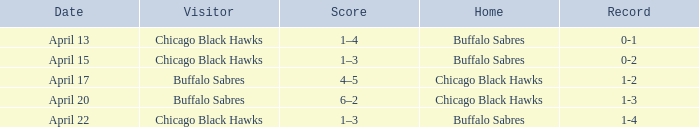Name the Visitor that has a Home of chicago black hawks on april 20? Buffalo Sabres. 